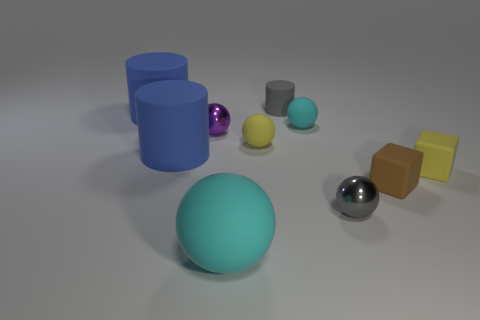Do the tiny yellow thing on the right side of the brown object and the gray thing on the left side of the small cyan sphere have the same material?
Make the answer very short. Yes. Is the number of small yellow rubber spheres that are in front of the tiny brown rubber object the same as the number of brown matte objects left of the tiny purple shiny sphere?
Offer a terse response. Yes. What is the big cylinder behind the tiny purple metal ball made of?
Offer a terse response. Rubber. Are there any other things that are the same size as the purple metallic object?
Keep it short and to the point. Yes. Is the number of tiny brown matte objects less than the number of blue rubber things?
Your answer should be very brief. Yes. What is the shape of the big thing that is behind the small brown matte cube and in front of the tiny cyan rubber ball?
Your answer should be compact. Cylinder. How many cyan metal balls are there?
Offer a very short reply. 0. What material is the small yellow object that is left of the matte cylinder on the right side of the thing in front of the small gray ball?
Make the answer very short. Rubber. There is a yellow object on the left side of the gray shiny thing; what number of rubber cylinders are in front of it?
Give a very brief answer. 1. The other large object that is the same shape as the purple object is what color?
Offer a very short reply. Cyan. 